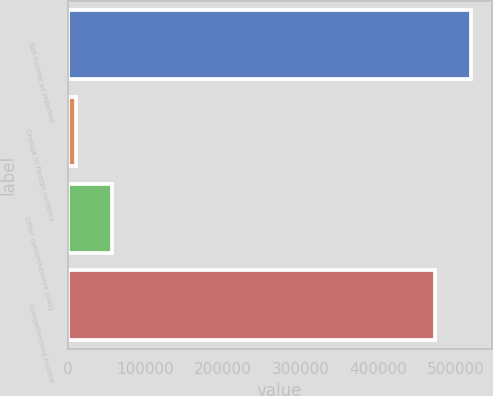<chart> <loc_0><loc_0><loc_500><loc_500><bar_chart><fcel>Net income as reported<fcel>Change in foreign currency<fcel>Other comprehensive (loss)<fcel>Comprehensive income<nl><fcel>520262<fcel>10220<fcel>57516.5<fcel>472965<nl></chart> 